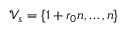Convert formula to latex. <formula><loc_0><loc_0><loc_500><loc_500>\mathcal { V } _ { s } = \{ 1 + r _ { 0 } n , \dots , n \}</formula> 